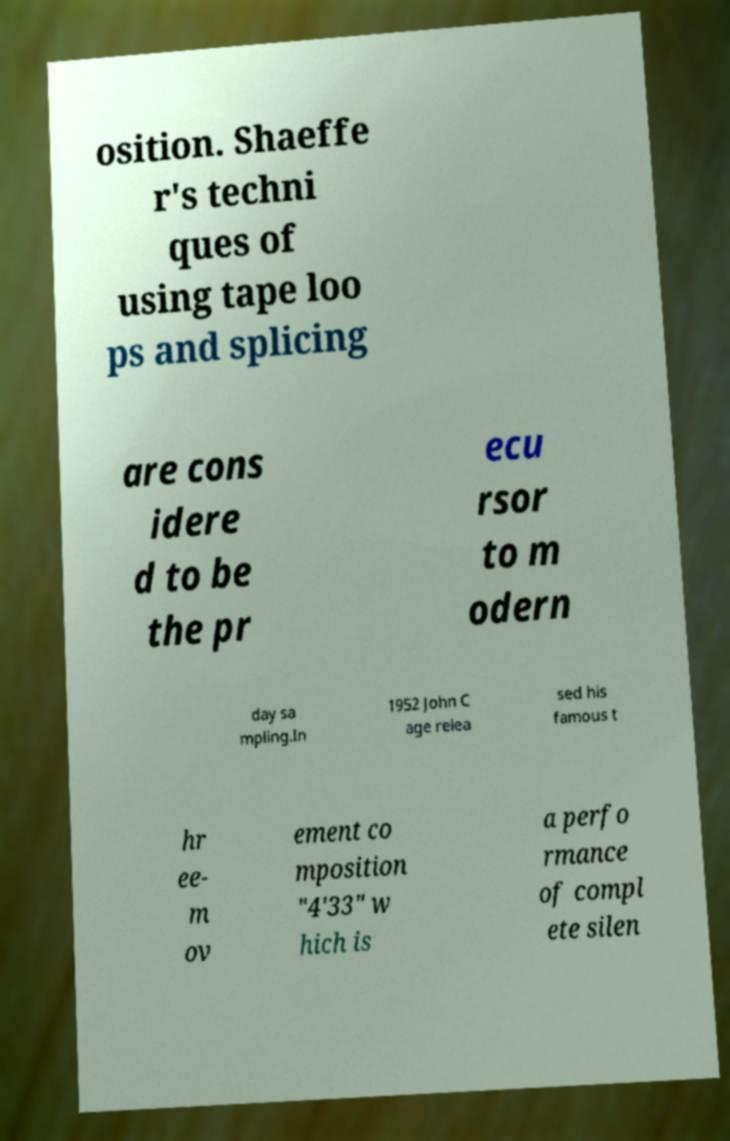Could you assist in decoding the text presented in this image and type it out clearly? osition. Shaeffe r's techni ques of using tape loo ps and splicing are cons idere d to be the pr ecu rsor to m odern day sa mpling.In 1952 John C age relea sed his famous t hr ee- m ov ement co mposition "4'33" w hich is a perfo rmance of compl ete silen 